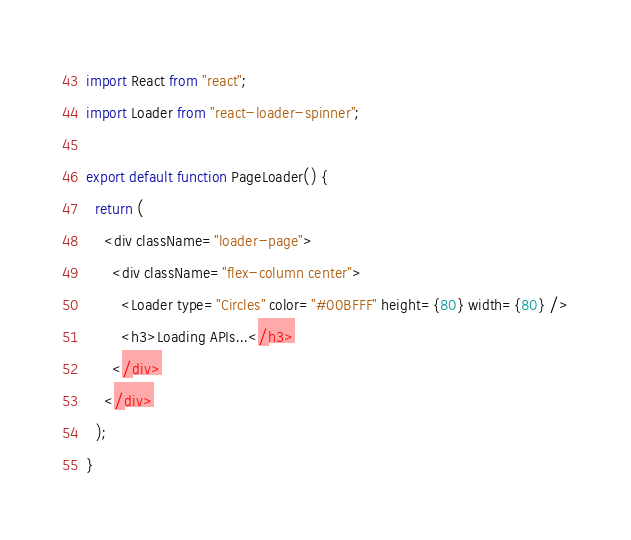Convert code to text. <code><loc_0><loc_0><loc_500><loc_500><_JavaScript_>import React from "react";
import Loader from "react-loader-spinner";

export default function PageLoader() {
  return (
    <div className="loader-page">
      <div className="flex-column center">
        <Loader type="Circles" color="#00BFFF" height={80} width={80} />
        <h3>Loading APIs...</h3>
      </div>
    </div>
  );
}
</code> 